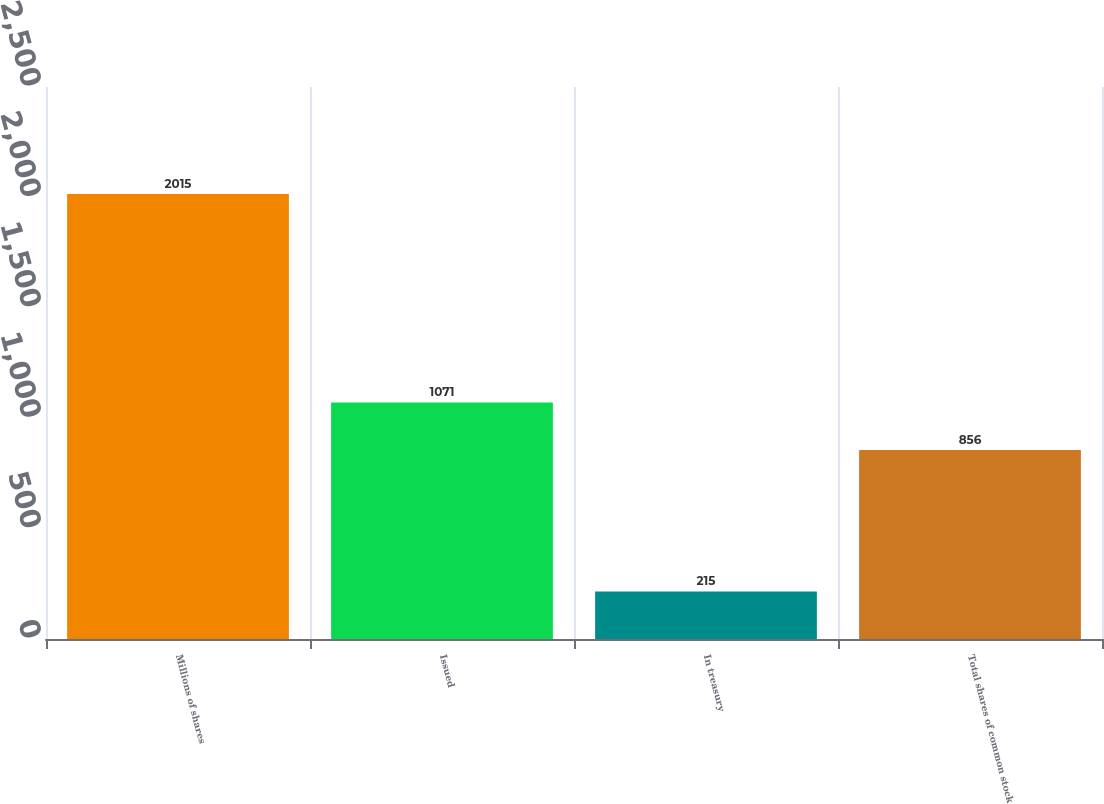Convert chart. <chart><loc_0><loc_0><loc_500><loc_500><bar_chart><fcel>Millions of shares<fcel>Issued<fcel>In treasury<fcel>Total shares of common stock<nl><fcel>2015<fcel>1071<fcel>215<fcel>856<nl></chart> 